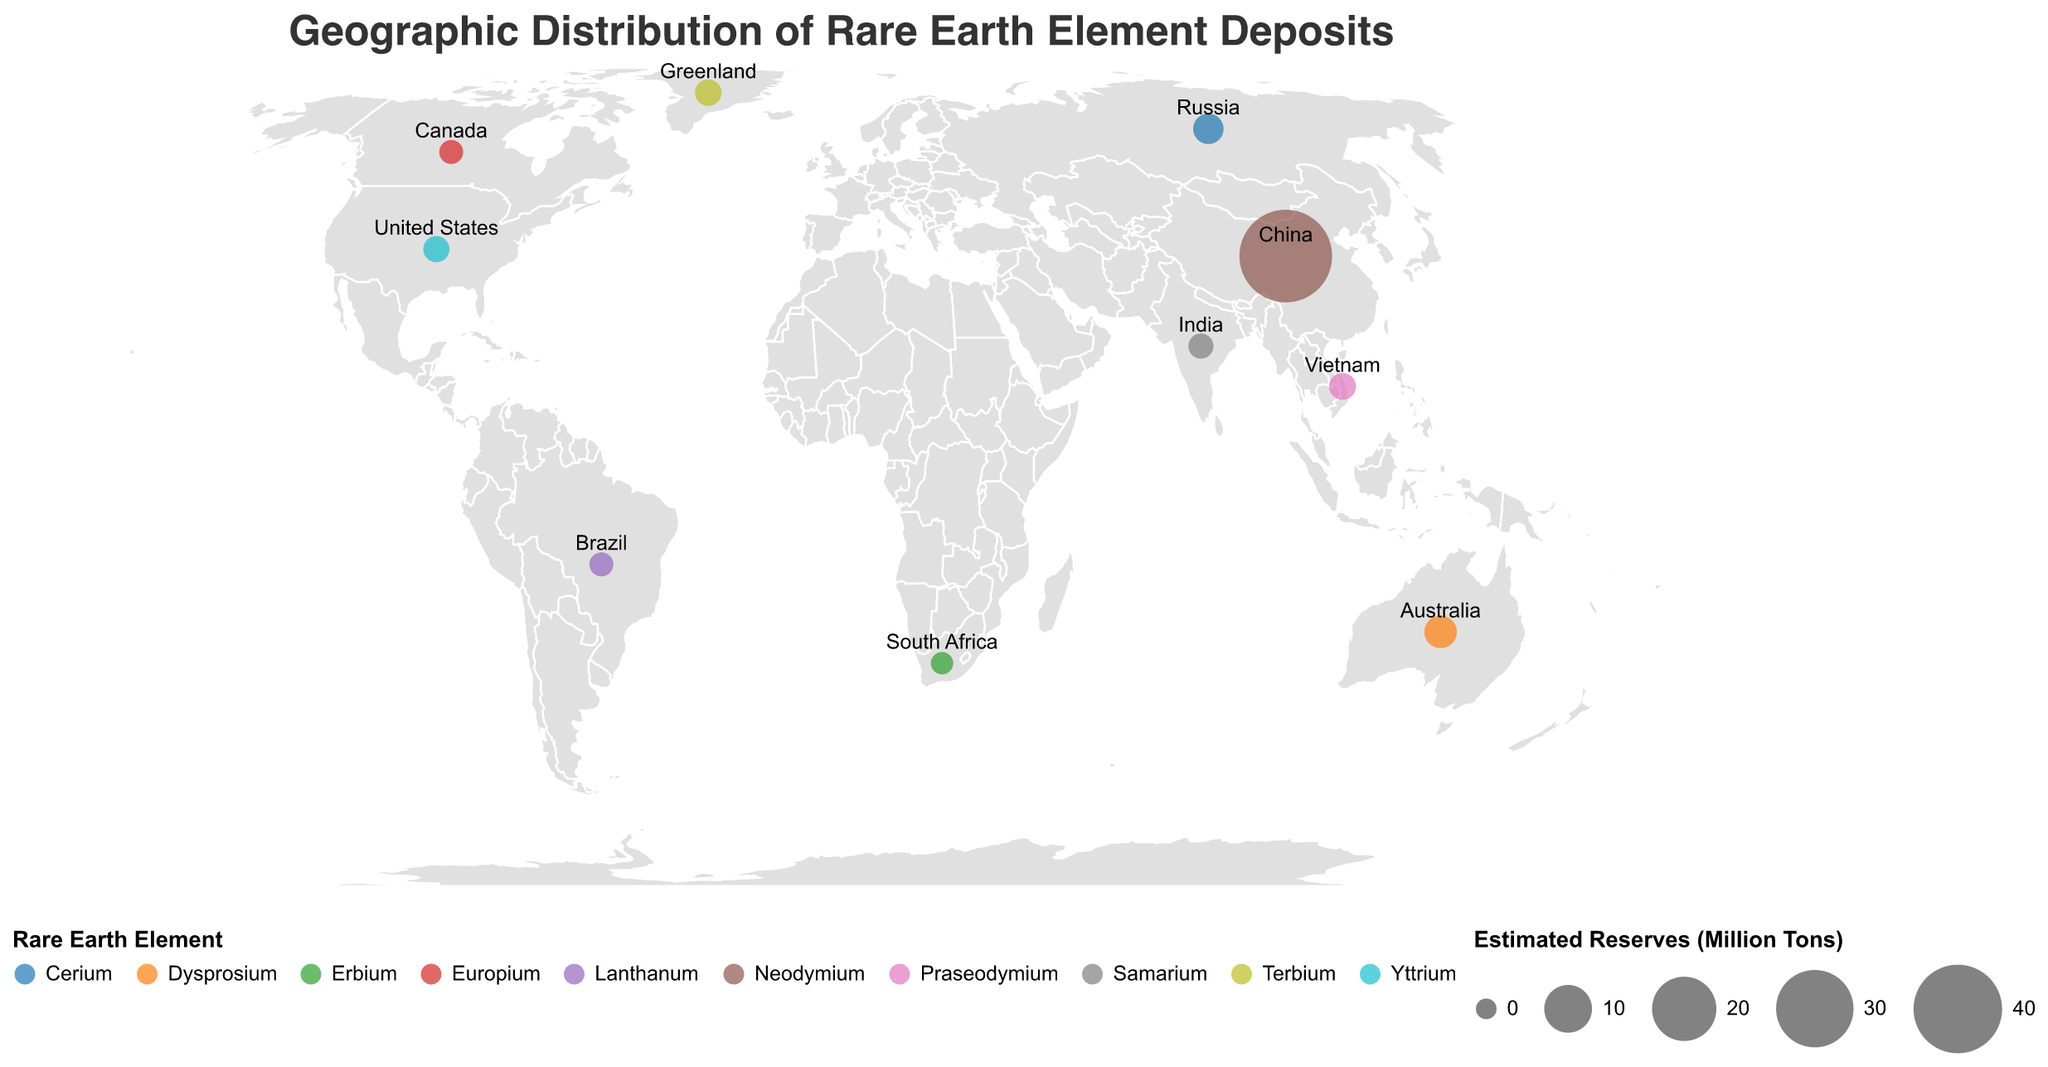What is the title of the figure? The title is usually displayed at the top of the figure and is "Geographic Distribution of Rare Earth Element Deposits"
Answer: Geographic Distribution of Rare Earth Element Deposits How many countries are shown on the plot? By counting the number of unique labeled countries on the map, we find there are 10 countries (China, Australia, United States, Brazil, Russia, India, Canada, Greenland, South Africa, Vietnam)
Answer: 10 Which country has the largest estimated reserves? By comparing the size of the circles, China has the largest circle, representing 44 million tons of Neodymium
Answer: China What is the rare earth element with the smallest estimated reserves, and which country does it belong to? By comparing the smallest circle size and referring to the tooltip, Erbium in South Africa with 0.4 million tons is the smallest
Answer: Erbium in South Africa How does the estimated reserve of Neodymium in China compare with the estimated reserve of Cerium in Russia? China (Neodymium) has 44 million tons, which is much larger than Russia's 2.7 million tons of Cerium
Answer: China has much larger reserves Which rare earth element is found in both the United States and India? By observing the color legend and locations, Yttrium is found in the United States and Samarium in India, no element overlaps
Answer: No overlap What is the combined estimated reserve of rare earth elements in the Americas (United States, Brazil, and Canada)? Summing up the reserves: United States (1.4) + Brazil (0.8) + Canada (0.8) = 3 million tons
Answer: 3 million tons What is the average estimated reserve of rare earth elements for the listed countries? Sum all reserves: 44+3.4+1.4+0.8+2.7+1.1+0.8+1.5+0.4+1.6 = 57.7 million tons; Average = 57.7 / 10 = 5.77 million tons
Answer: 5.77 million tons Which countries lie in the Southern Hemisphere, and what rare earth elements do they have? By observing latitude values less than 0: Australia (Dysprosium), Brazil (Lanthanum), South Africa (Erbium)
Answer: Australia (Dysprosium), Brazil (Lanthanum), South Africa (Erbium) In terms of geographic distribution, which continent appears to have the most diverse range of rare earth elements? Observing the spread across continents and different colors, Asia has several countries with different elements (China, India, Vietnam)
Answer: Asia 